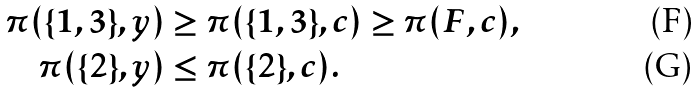Convert formula to latex. <formula><loc_0><loc_0><loc_500><loc_500>\pi ( \{ 1 , 3 \} , y ) & \geq \pi ( \{ 1 , 3 \} , c ) \geq \pi ( F , c ) , \\ \pi ( \{ 2 \} , y ) & \leq \pi ( \{ 2 \} , c ) .</formula> 